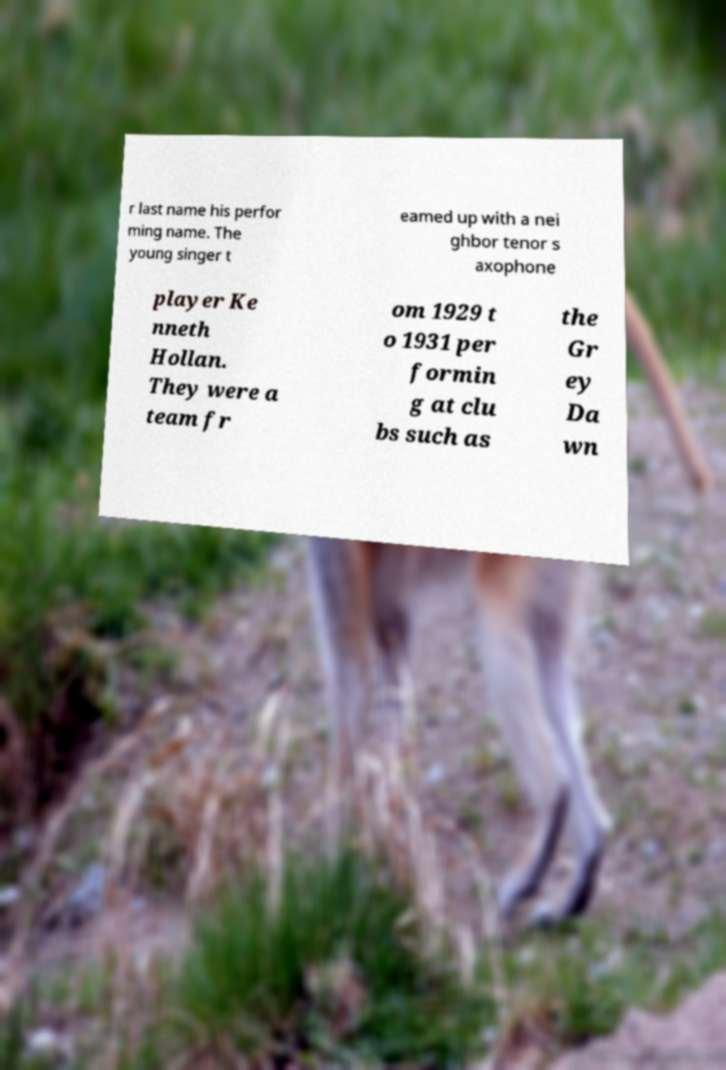Please read and relay the text visible in this image. What does it say? r last name his perfor ming name. The young singer t eamed up with a nei ghbor tenor s axophone player Ke nneth Hollan. They were a team fr om 1929 t o 1931 per formin g at clu bs such as the Gr ey Da wn 